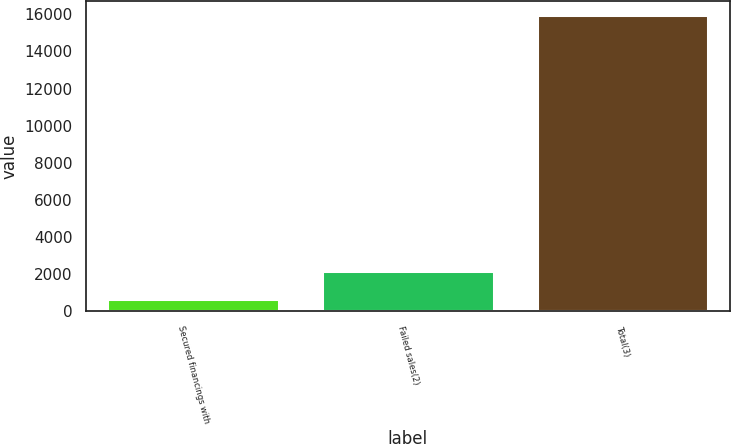Convert chart to OTSL. <chart><loc_0><loc_0><loc_500><loc_500><bar_chart><fcel>Secured financings with<fcel>Failed sales(2)<fcel>Total(3)<nl><fcel>641<fcel>2149.6<fcel>15939.6<nl></chart> 